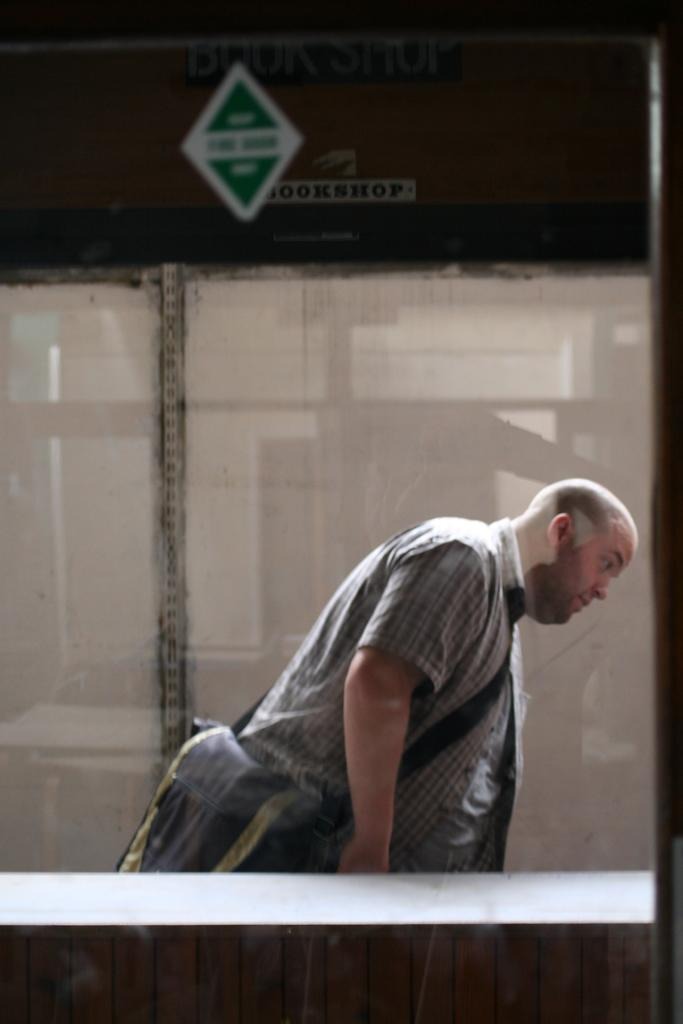Who is present in the image? There is a man in the image. What is the man doing in the image? The man is standing in the image. What is the man wearing in the image? The man is wearing a bag in the image. Where is the man located in the image? The man is beside a building in the image. What is the chance of finding a nest on top of the man in the image? There is no nest present on top of the man in the image, and therefore no such chance can be determined. 